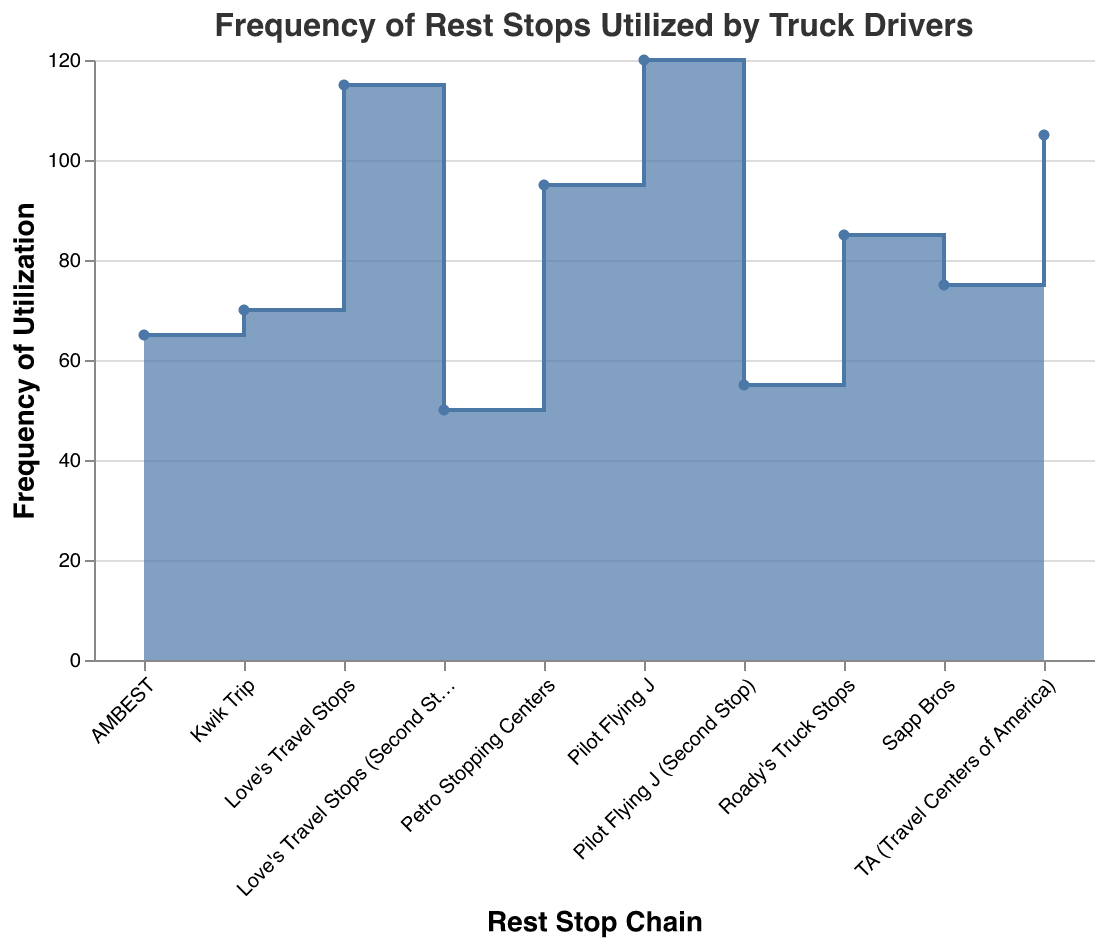What is the title of the step area chart? The title is displayed at the top of the chart and provides a brief description of what the chart is about.
Answer: Frequency of Rest Stops Utilized by Truck Drivers How many rest stops are listed in the chart? Count the number of unique rest stops mentioned along the x-axis.
Answer: 10 Which rest stop has the highest frequency of utilization? Look for the highest data point on the y-axis and note the corresponding rest stop on the x-axis.
Answer: Pilot Flying J What is the utilization frequency difference between Pilot Flying J and Love's Travel Stops? Subtract the frequency of Love's Travel Stops from the frequency of Pilot Flying J.
Answer: 5 Which rest stop chains are included in both the initial and second stop categories? Look for rest stops that have both their initial and second stops mentioned in the chart.
Answer: Pilot Flying J, Love's Travel Stops What is the total frequency of the top three most-utilized rest stops? Add the frequencies of the top three rest stops: Pilot Flying J, Love's Travel Stops, and TA (Travel Centers of America).
Answer: 340 How does the frequency utilization change from Pilot Flying J (initial stop) to Pilot Flying J (second stop)? Observe the frequencies and calculate the decrease by subtracting the second stop's frequency from the initial stop's frequency.
Answer: 65 Which rest stop has the lowest frequency of utilization? Identify the smallest data point on the y-axis and note the corresponding rest stop on the x-axis.
Answer: Love's Travel Stops (Second Stop) What is the average frequency of all rest stops listed in the chart? Sum all frequencies and divide by the total number of rest stops.
Answer: 83.5 How does the area under the steps change after TA (Travel Centers of America)? Observe the sequential drop in the step areas after TA (Travel Centers of America) and note the general trend (smooth or steep).
Answer: Steadily decreases 